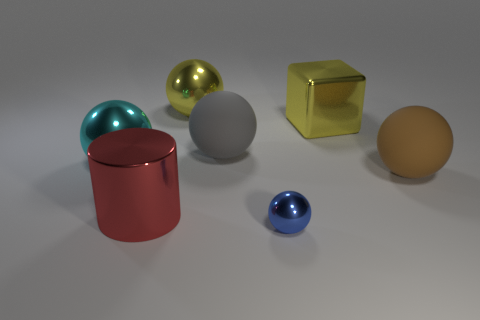Subtract 2 spheres. How many spheres are left? 3 Subtract all cyan balls. How many balls are left? 4 Subtract all blue balls. How many balls are left? 4 Subtract all purple balls. Subtract all gray cylinders. How many balls are left? 5 Add 3 big balls. How many objects exist? 10 Subtract all blocks. How many objects are left? 6 Add 1 big brown shiny cylinders. How many big brown shiny cylinders exist? 1 Subtract 0 brown cylinders. How many objects are left? 7 Subtract all shiny objects. Subtract all big brown balls. How many objects are left? 1 Add 5 big cyan metal balls. How many big cyan metal balls are left? 6 